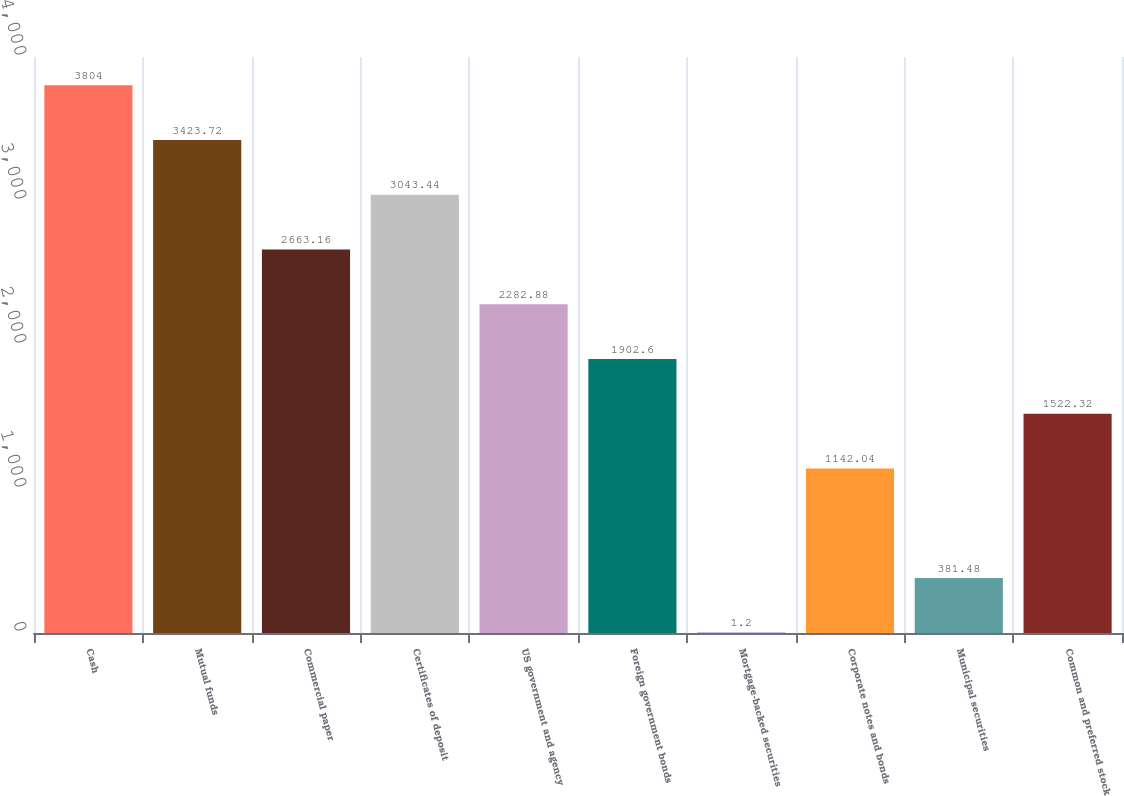Convert chart to OTSL. <chart><loc_0><loc_0><loc_500><loc_500><bar_chart><fcel>Cash<fcel>Mutual funds<fcel>Commercial paper<fcel>Certificates of deposit<fcel>US government and agency<fcel>Foreign government bonds<fcel>Mortgage-backed securities<fcel>Corporate notes and bonds<fcel>Municipal securities<fcel>Common and preferred stock<nl><fcel>3804<fcel>3423.72<fcel>2663.16<fcel>3043.44<fcel>2282.88<fcel>1902.6<fcel>1.2<fcel>1142.04<fcel>381.48<fcel>1522.32<nl></chart> 